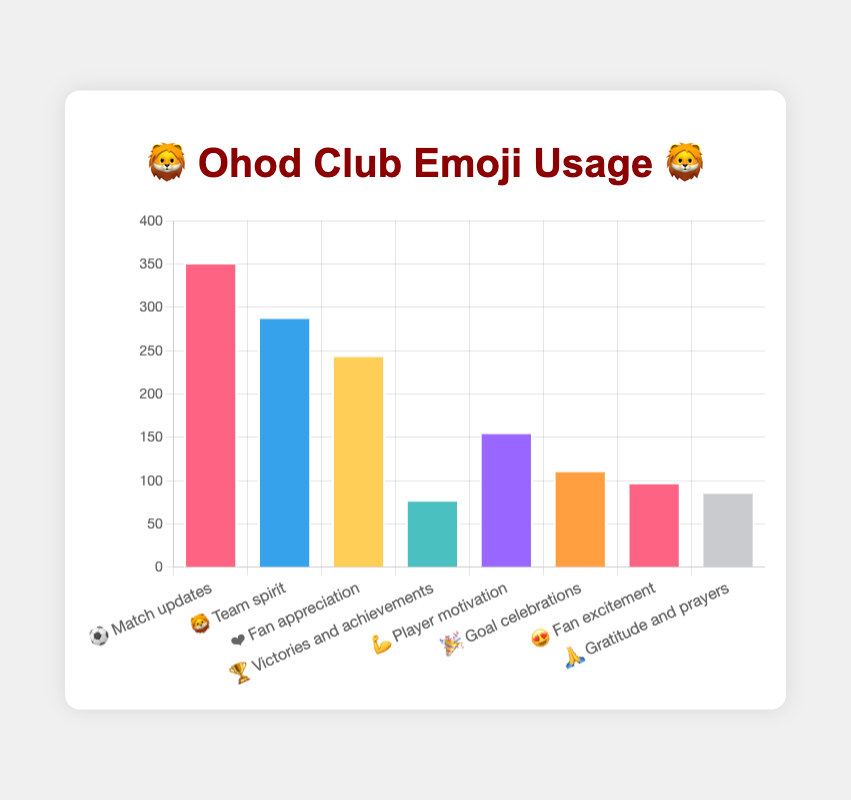Which emoji is used the most in Ohod Club's social media posts? From the height of the bars, we can see that the "⚽" emoji has the highest count.
Answer: ⚽ What is the total count of the "💪" and "🎉" emoji combined? The "💪" emoji has a count of 156 and the "🎉" emoji has a count of 112. Adding these together, 156 + 112 = 268.
Answer: 268 Which emoji related to team spirit is most used in the posts? From the labels, the "Team spirit" context is represented by the "🦁" emoji, which is visibly tall and has a count of 289.
Answer: 🦁 By how much does the usage of "❤️" exceed the usage of "🦁"? The "❤️" emoji has a count of 245 and the "🦁" has a count of 289. The difference is 289 - 245 = 44.
Answer: 44 Which emoji indicates gratitude and how many times is it used? Checking the context labels, the "🙏" emoji is used for gratitude and has a count of 87.
Answer: 🙏, 87 What is the least frequently used emoji and its context? The shortest bar corresponds to the "🏆" emoji, which has the lowest count of 78. Its context is "Victories and achievements."
Answer: 🏆, "Victories and achievements" What is the combined usage of emojis related to fan interactions ("Fan appreciation" and "Fan excitement")? The "❤️" emoji (Fan appreciation) has 245 uses, and the "😍" emoji (Fan excitement) has 98 uses. Combined, 245 + 98 = 343.
Answer: 343 How many more times is the "Match updates" emoji used than "Goal celebrations" emoji? The "⚽" emoji (Match updates) has a count of 352, and the "🎉" emoji has 112. The difference is 352 - 112 = 240.
Answer: 240 Which emoji is used less frequently than "Player motivation" but more frequently than "Gratitude and prayers"? The "😍" emoji is used 98 times, which is less than "💪" (156 times) but more than "🙏" (87 times).
Answer: 😍 